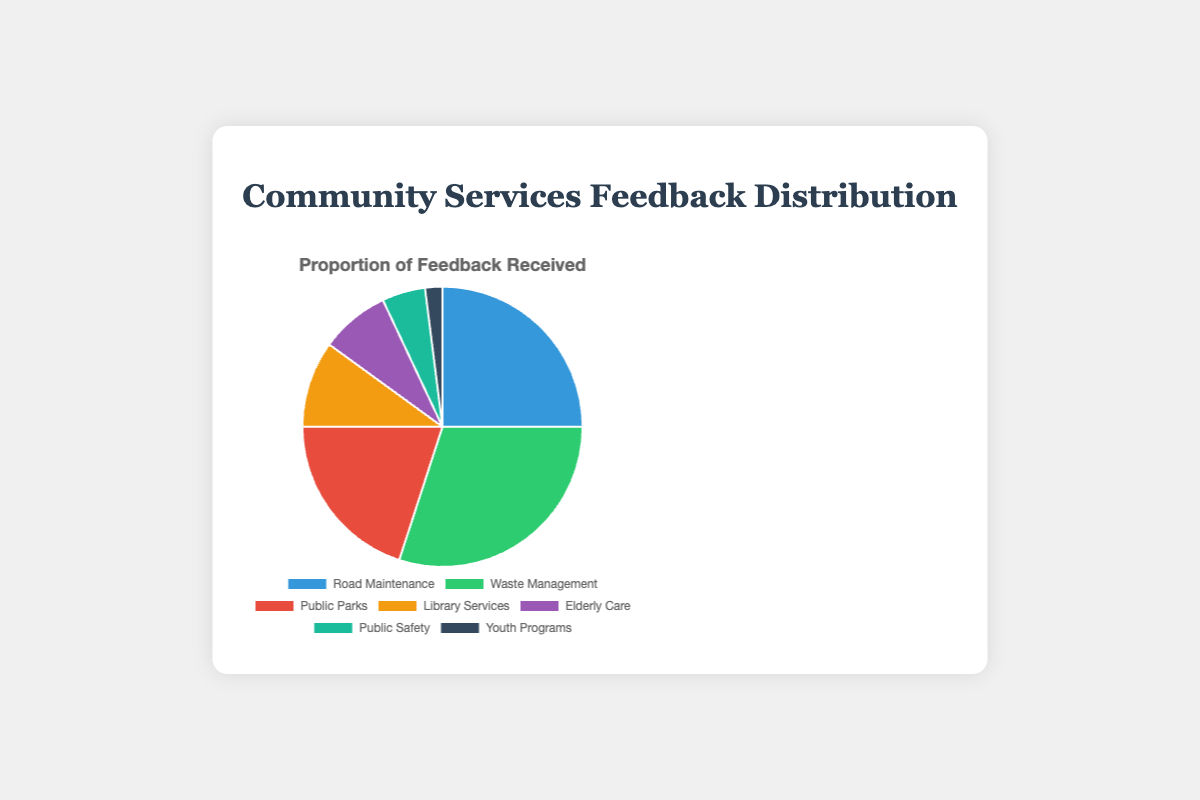Which community service received the most feedback? The segment representing Waste Management is the largest in the pie chart.
Answer: Waste Management How does the feedback for Road Maintenance compare to Public Parks? Comparing the sizes of the segments, Road Maintenance appears larger than Public Parks.
Answer: Road Maintenance received more feedback What is the combined feedback percentage for Elderly Care and Youth Programs? Elderly Care received 8% and Youth Programs received 2%. Adding these together gives 8% + 2% = 10%.
Answer: 10% Which color represents Waste Management? The segment for Waste Management is the largest and colored green.
Answer: Green What fraction of the total feedback pertains to Library Services? Library Services received 10% of the feedback.
Answer: 10% Is Public Safety's feedback less than 10%? The segment for Public Safety is smaller than the segment for Library Services, which is 10%. Therefore, Public Safety is less than 10%.
Answer: Yes Which service has the smallest segment in the pie chart? The smallest segment visible in the pie chart represents Youth Programs.
Answer: Youth Programs What is the total percentage of feedback for Road Maintenance, Public Safety, and Public Parks combined? Adding their individual feedback percentages: Road Maintenance (25%) + Public Safety (5%) + Public Parks (20%) = 50%.
Answer: 50% What two services combined have approximately the same feedback as Waste Management? Road Maintenance (25%) and Library Services (10%) together sum to 25% + 10% = 35%, which is approximately equal to Waste Management's 30%.
Answer: Road Maintenance and Library Services How many services received less feedback than Library Services? Elderly Care (8%), Public Safety (5%), and Youth Programs (2%) each received less feedback than Library Services (10%).
Answer: Three services 